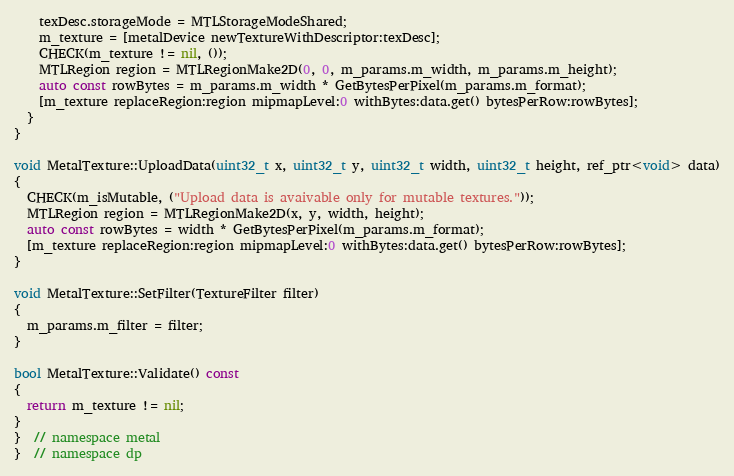<code> <loc_0><loc_0><loc_500><loc_500><_ObjectiveC_>    texDesc.storageMode = MTLStorageModeShared;
    m_texture = [metalDevice newTextureWithDescriptor:texDesc];
    CHECK(m_texture != nil, ());
    MTLRegion region = MTLRegionMake2D(0, 0, m_params.m_width, m_params.m_height);
    auto const rowBytes = m_params.m_width * GetBytesPerPixel(m_params.m_format);
    [m_texture replaceRegion:region mipmapLevel:0 withBytes:data.get() bytesPerRow:rowBytes];
  }
}

void MetalTexture::UploadData(uint32_t x, uint32_t y, uint32_t width, uint32_t height, ref_ptr<void> data)
{
  CHECK(m_isMutable, ("Upload data is avaivable only for mutable textures."));
  MTLRegion region = MTLRegionMake2D(x, y, width, height);
  auto const rowBytes = width * GetBytesPerPixel(m_params.m_format);
  [m_texture replaceRegion:region mipmapLevel:0 withBytes:data.get() bytesPerRow:rowBytes];
}

void MetalTexture::SetFilter(TextureFilter filter)
{
  m_params.m_filter = filter;
}

bool MetalTexture::Validate() const
{
  return m_texture != nil;
}
}  // namespace metal
}  // namespace dp
</code> 